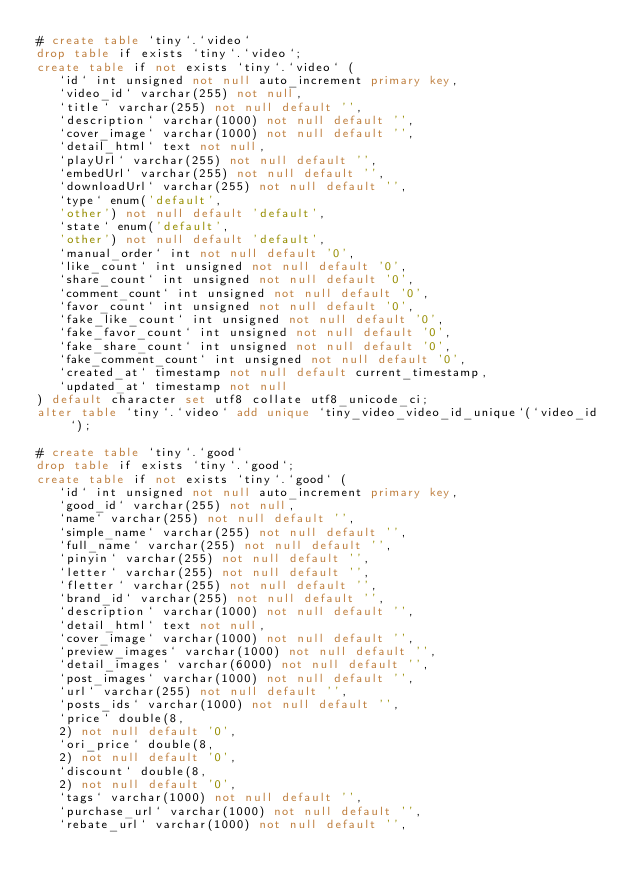Convert code to text. <code><loc_0><loc_0><loc_500><loc_500><_SQL_># create table `tiny`.`video`
drop table if exists `tiny`.`video`;
create table if not exists `tiny`.`video` (
   `id` int unsigned not null auto_increment primary key,
   `video_id` varchar(255) not null,
   `title` varchar(255) not null default '',
   `description` varchar(1000) not null default '',
   `cover_image` varchar(1000) not null default '',
   `detail_html` text not null,
   `playUrl` varchar(255) not null default '',
   `embedUrl` varchar(255) not null default '',
   `downloadUrl` varchar(255) not null default '',
   `type` enum('default',
   'other') not null default 'default',
   `state` enum('default',
   'other') not null default 'default',
   `manual_order` int not null default '0',
   `like_count` int unsigned not null default '0',
   `share_count` int unsigned not null default '0',
   `comment_count` int unsigned not null default '0',
   `favor_count` int unsigned not null default '0',
   `fake_like_count` int unsigned not null default '0',
   `fake_favor_count` int unsigned not null default '0',
   `fake_share_count` int unsigned not null default '0',
   `fake_comment_count` int unsigned not null default '0',
   `created_at` timestamp not null default current_timestamp,
   `updated_at` timestamp not null
) default character set utf8 collate utf8_unicode_ci;
alter table `tiny`.`video` add unique `tiny_video_video_id_unique`(`video_id`);

# create table `tiny`.`good`
drop table if exists `tiny`.`good`;
create table if not exists `tiny`.`good` (
   `id` int unsigned not null auto_increment primary key,
   `good_id` varchar(255) not null,
   `name` varchar(255) not null default '',
   `simple_name` varchar(255) not null default '',
   `full_name` varchar(255) not null default '',
   `pinyin` varchar(255) not null default '',
   `letter` varchar(255) not null default '',
   `fletter` varchar(255) not null default '',
   `brand_id` varchar(255) not null default '',
   `description` varchar(1000) not null default '',
   `detail_html` text not null,
   `cover_image` varchar(1000) not null default '',
   `preview_images` varchar(1000) not null default '',
   `detail_images` varchar(6000) not null default '',
   `post_images` varchar(1000) not null default '',
   `url` varchar(255) not null default '',
   `posts_ids` varchar(1000) not null default '',
   `price` double(8,
   2) not null default '0',
   `ori_price` double(8,
   2) not null default '0',
   `discount` double(8,
   2) not null default '0',
   `tags` varchar(1000) not null default '',
   `purchase_url` varchar(1000) not null default '',
   `rebate_url` varchar(1000) not null default '',</code> 